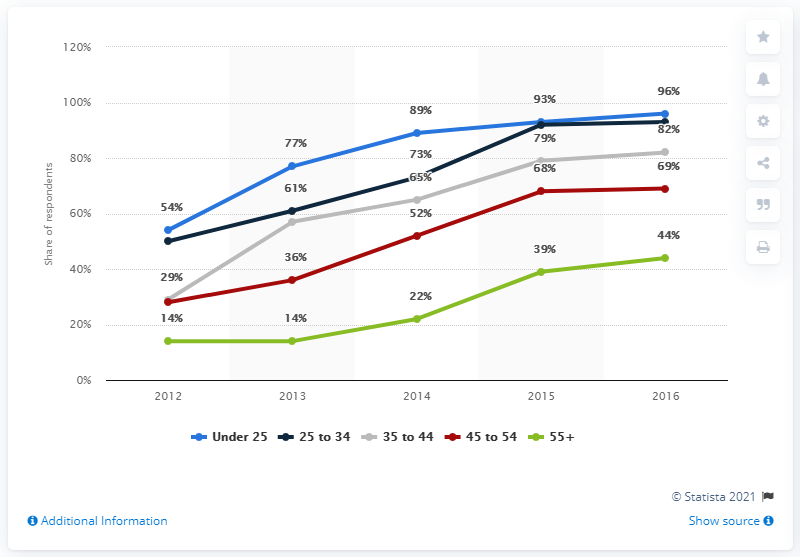Point out several critical features in this image. The green color indicates the result of the addition of 55+... The sum of the maximum and minimum number of users under 25 is 150. 